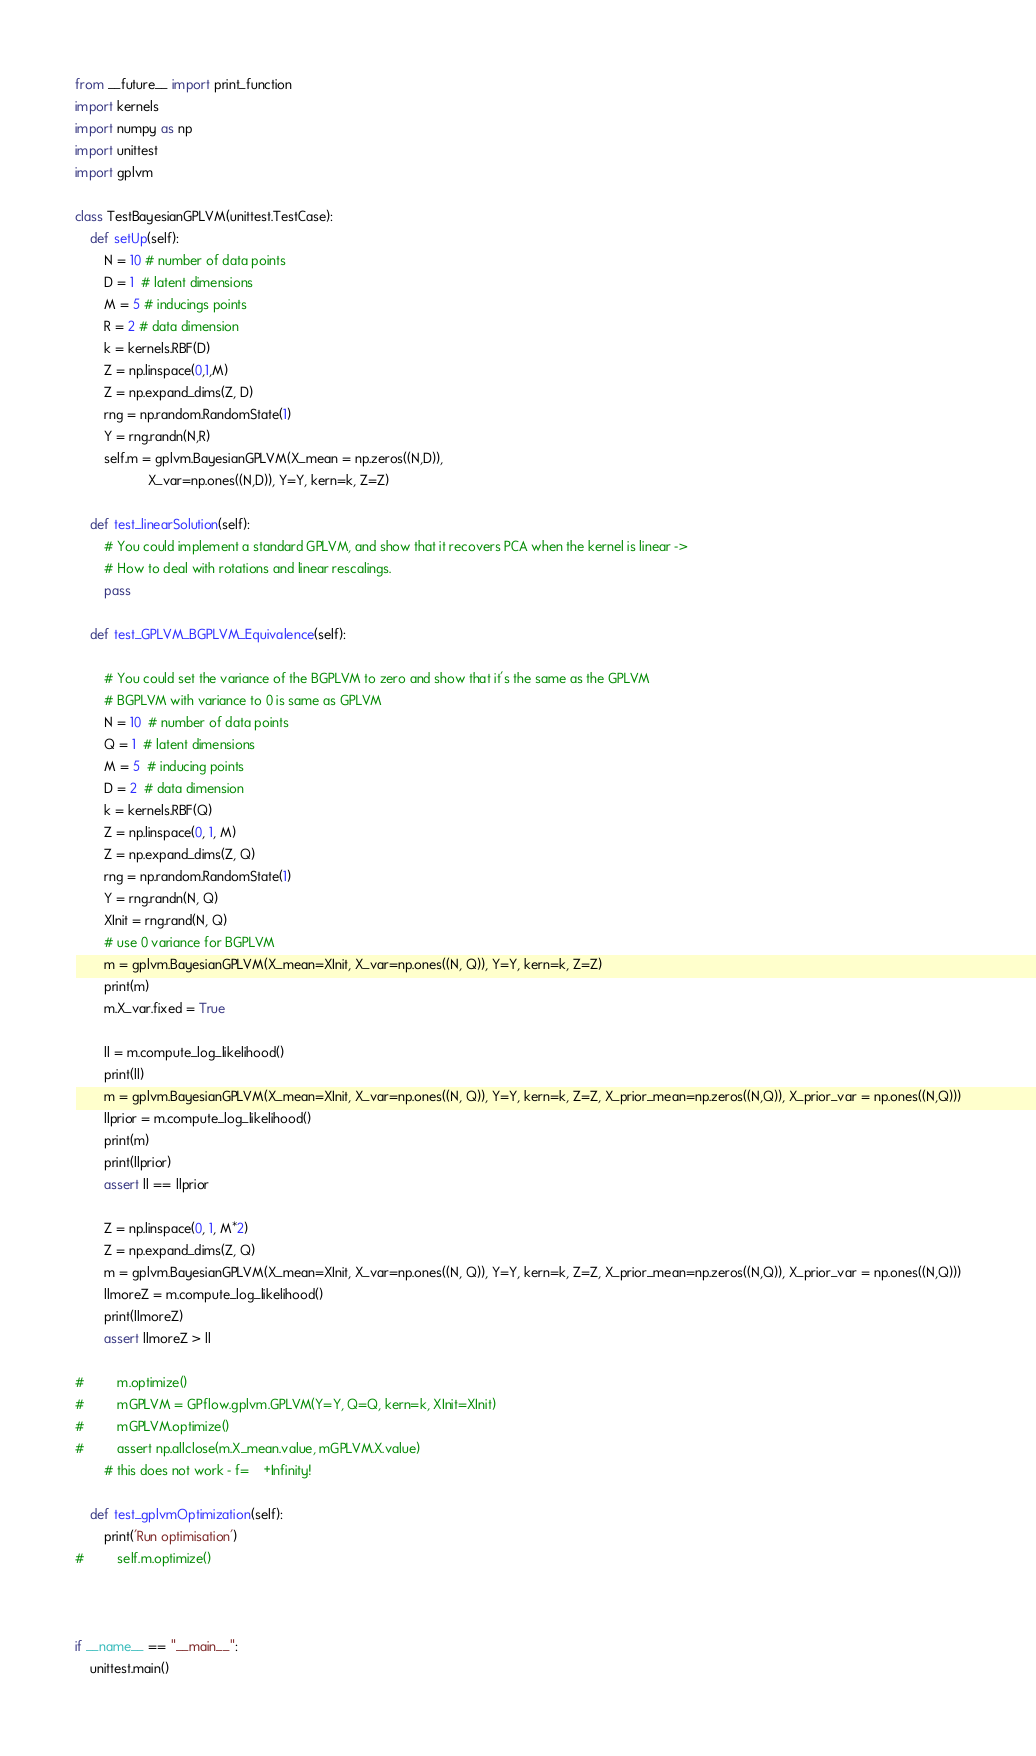<code> <loc_0><loc_0><loc_500><loc_500><_Python_>from __future__ import print_function
import kernels
import numpy as np
import unittest
import gplvm

class TestBayesianGPLVM(unittest.TestCase):
    def setUp(self):
        N = 10 # number of data points
        D = 1  # latent dimensions
        M = 5 # inducings points
        R = 2 # data dimension
        k = kernels.RBF(D)
        Z = np.linspace(0,1,M)
        Z = np.expand_dims(Z, D)
        rng = np.random.RandomState(1)
        Y = rng.randn(N,R)
        self.m = gplvm.BayesianGPLVM(X_mean = np.zeros((N,D)),
                    X_var=np.ones((N,D)), Y=Y, kern=k, Z=Z)

    def test_linearSolution(self):
        # You could implement a standard GPLVM, and show that it recovers PCA when the kernel is linear -> 
        # How to deal with rotations and linear rescalings.
        pass

    def test_GPLVM_BGPLVM_Equivalence(self):

        # You could set the variance of the BGPLVM to zero and show that it's the same as the GPLVM
        # BGPLVM with variance to 0 is same as GPLVM
        N = 10  # number of data points
        Q = 1  # latent dimensions
        M = 5  # inducing points
        D = 2  # data dimension
        k = kernels.RBF(Q)
        Z = np.linspace(0, 1, M)
        Z = np.expand_dims(Z, Q)
        rng = np.random.RandomState(1)
        Y = rng.randn(N, Q)
        XInit = rng.rand(N, Q)
        # use 0 variance for BGPLVM
        m = gplvm.BayesianGPLVM(X_mean=XInit, X_var=np.ones((N, Q)), Y=Y, kern=k, Z=Z)
        print(m)
        m.X_var.fixed = True

        ll = m.compute_log_likelihood()
        print(ll)
        m = gplvm.BayesianGPLVM(X_mean=XInit, X_var=np.ones((N, Q)), Y=Y, kern=k, Z=Z, X_prior_mean=np.zeros((N,Q)), X_prior_var = np.ones((N,Q)))
        llprior = m.compute_log_likelihood()
        print(m) 
        print(llprior)
        assert ll == llprior
 
        Z = np.linspace(0, 1, M*2)
        Z = np.expand_dims(Z, Q)
        m = gplvm.BayesianGPLVM(X_mean=XInit, X_var=np.ones((N, Q)), Y=Y, kern=k, Z=Z, X_prior_mean=np.zeros((N,Q)), X_prior_var = np.ones((N,Q)))
        llmoreZ = m.compute_log_likelihood()
        print(llmoreZ)
        assert llmoreZ > ll
        
#         m.optimize()
#         mGPLVM = GPflow.gplvm.GPLVM(Y=Y, Q=Q, kern=k, XInit=XInit)
#         mGPLVM.optimize()
#         assert np.allclose(m.X_mean.value, mGPLVM.X.value)
        # this does not work - f=    +Infinity!

    def test_gplvmOptimization(self):
        print('Run optimisation')
#         self.m.optimize()
    


if __name__ == "__main__":
    unittest.main()

</code> 